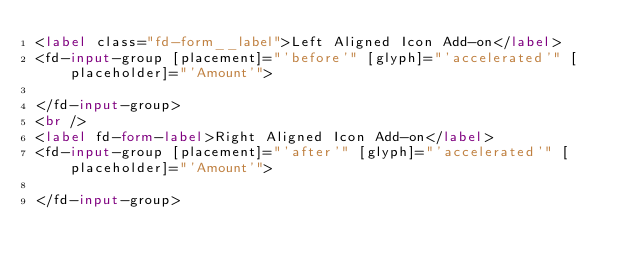Convert code to text. <code><loc_0><loc_0><loc_500><loc_500><_HTML_><label class="fd-form__label">Left Aligned Icon Add-on</label>
<fd-input-group [placement]="'before'" [glyph]="'accelerated'" [placeholder]="'Amount'">

</fd-input-group>
<br />
<label fd-form-label>Right Aligned Icon Add-on</label>
<fd-input-group [placement]="'after'" [glyph]="'accelerated'" [placeholder]="'Amount'">

</fd-input-group></code> 